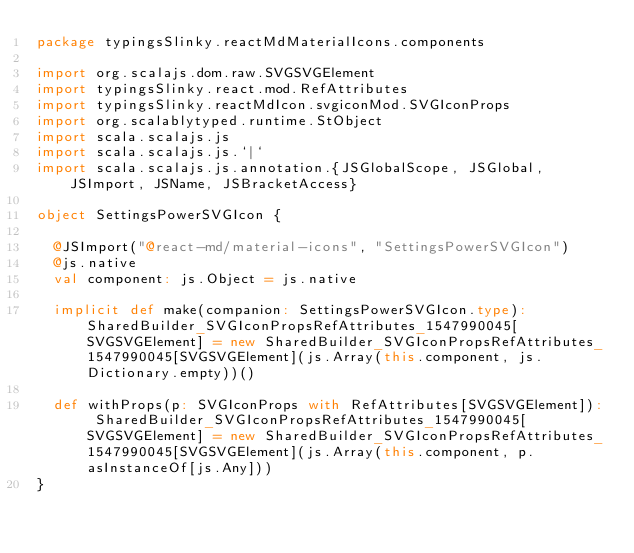<code> <loc_0><loc_0><loc_500><loc_500><_Scala_>package typingsSlinky.reactMdMaterialIcons.components

import org.scalajs.dom.raw.SVGSVGElement
import typingsSlinky.react.mod.RefAttributes
import typingsSlinky.reactMdIcon.svgiconMod.SVGIconProps
import org.scalablytyped.runtime.StObject
import scala.scalajs.js
import scala.scalajs.js.`|`
import scala.scalajs.js.annotation.{JSGlobalScope, JSGlobal, JSImport, JSName, JSBracketAccess}

object SettingsPowerSVGIcon {
  
  @JSImport("@react-md/material-icons", "SettingsPowerSVGIcon")
  @js.native
  val component: js.Object = js.native
  
  implicit def make(companion: SettingsPowerSVGIcon.type): SharedBuilder_SVGIconPropsRefAttributes_1547990045[SVGSVGElement] = new SharedBuilder_SVGIconPropsRefAttributes_1547990045[SVGSVGElement](js.Array(this.component, js.Dictionary.empty))()
  
  def withProps(p: SVGIconProps with RefAttributes[SVGSVGElement]): SharedBuilder_SVGIconPropsRefAttributes_1547990045[SVGSVGElement] = new SharedBuilder_SVGIconPropsRefAttributes_1547990045[SVGSVGElement](js.Array(this.component, p.asInstanceOf[js.Any]))
}
</code> 